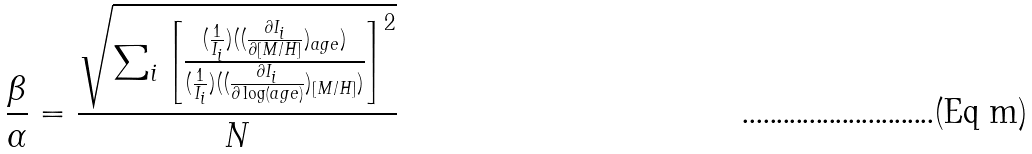Convert formula to latex. <formula><loc_0><loc_0><loc_500><loc_500>\frac { \beta } { \alpha } = \frac { \sqrt { \sum _ { i } \left [ \frac { ( \frac { 1 } { I _ { i } } ) ( ( \frac { \partial I _ { i } } { \partial [ M / H ] } ) _ { a g e } ) } { ( \frac { 1 } { I _ { i } } ) ( ( \frac { \partial I _ { i } } { \partial \log ( a g e ) } ) _ { [ M / H ] } ) } \right ] ^ { 2 } } } { N }</formula> 